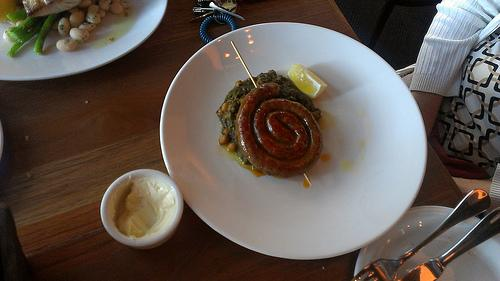What can you deduce about the use of silverware in this scenario? The silverware, consisting of two forks and a knife, is essential for eating the meal served on the table, particularly the sausages and other food items requiring cutting or piercing. Can you give a detailed description of the table in the image? The table is brown and wooden with several objects on it, including three white plates, a dish of butter, silverware, beans, a lemon wedge, roll of cooked sausage, and a set of keys with a blue keychain. How would you describe the individual's attire, and what is their current action? The individual is wearing a white sweater, with the sleeve of the sweater visible, and they are seated at the table, ready to eat their meal. Can you identify any unusual object interactions in the image? An unusual object interaction is the presence of a set of keys with a blue keychain placed beside a plate on the table, indicating that the person might have just arrived or is ready to leave. Briefly describe any additional food items or condiments found in the image. Other food items in the image include brown and green beans, yellow butter in a small white bowl, a small cut of lemon, and scattered food crumbs around the table. Please quantify the number of white plates, silverware, and keys visible in the image. There are three white plates, two silver forks, a silver metal knife, and a set of keys visible in the image. What is the main sentiment evoked by the image, and why do you feel that way? The sentiment evoked by the image is a sense of warmth and comfort, as it displays a person ready to enjoy a delicious meal on a wooden table with various food items. What are some of the items found on the large white plate? The large white plate contains cooked sausage, beans, chick peas, and a yellow lemon wedge. In this scenario, what is the primary activity taking place? A person is sitting at a table with a meal consisting of various food items and silverware, prepared to eat. 